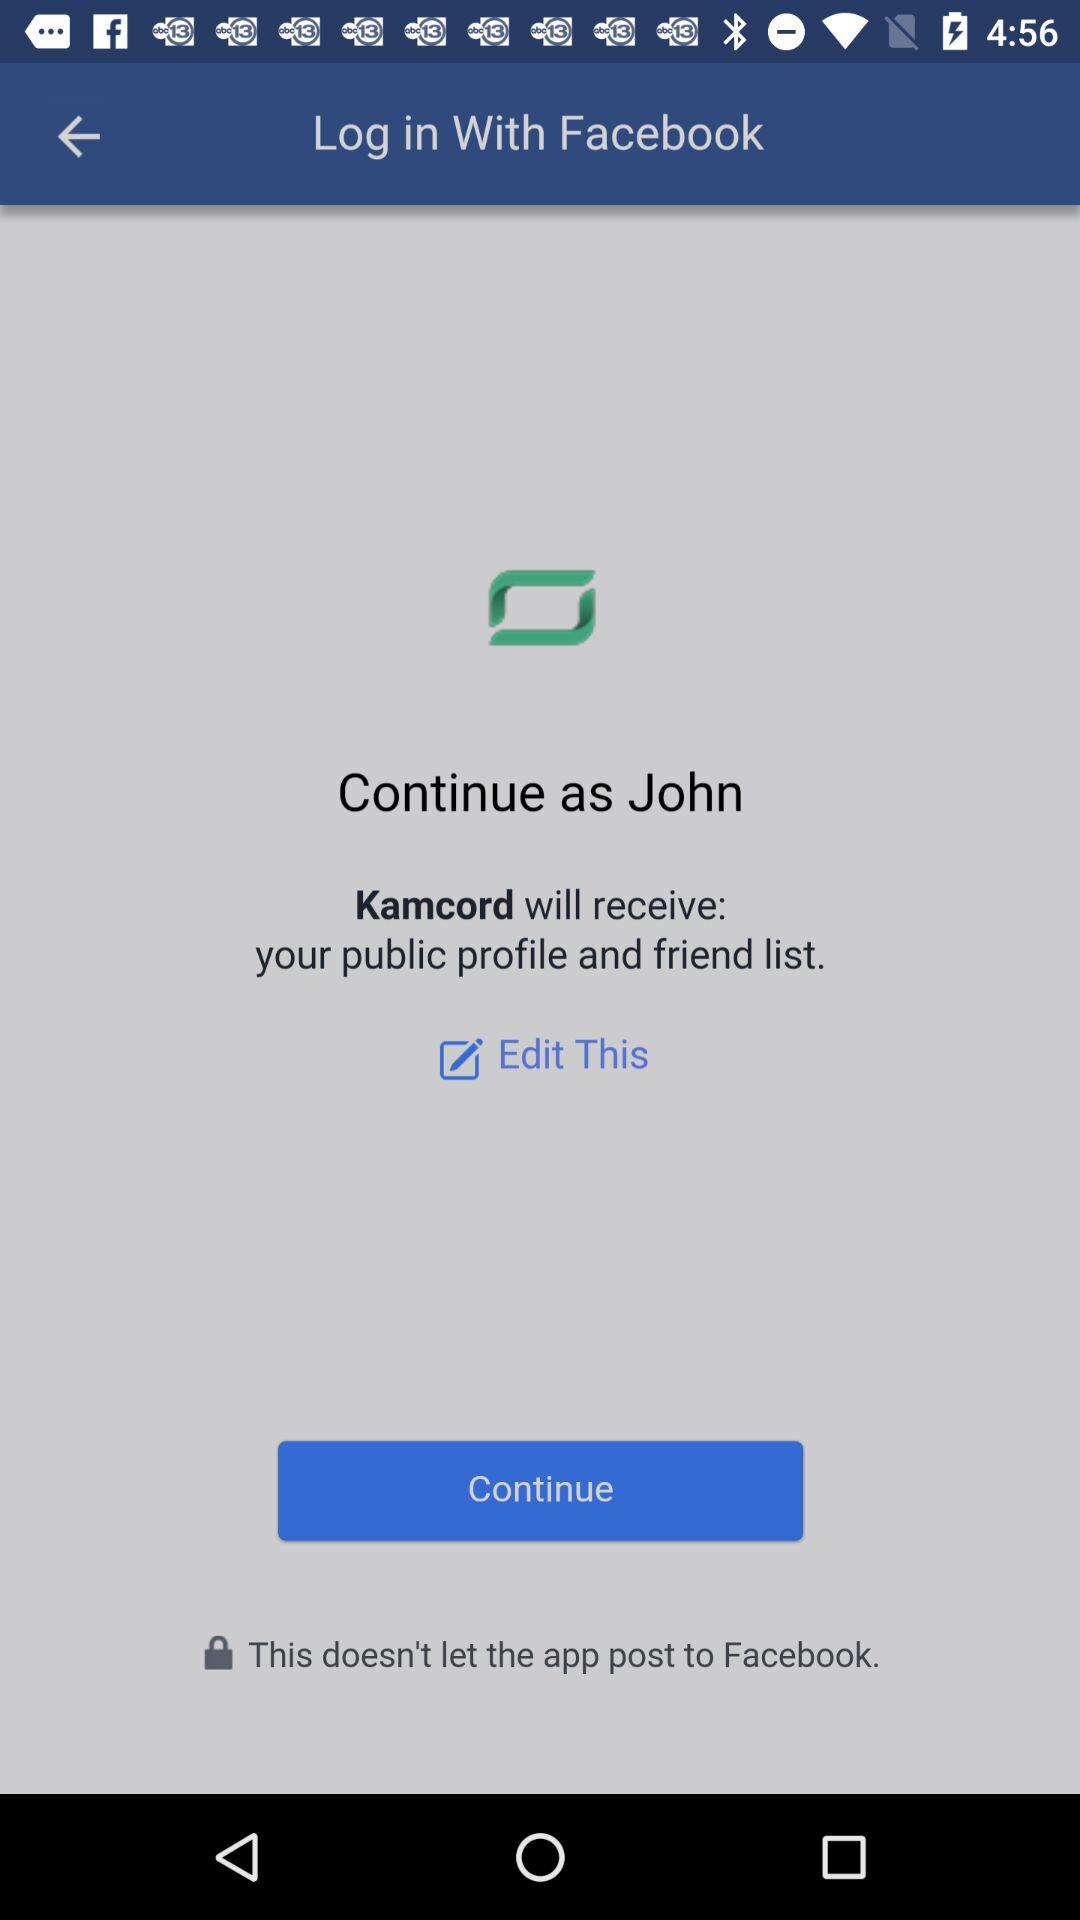Through what application is the person logging in? The person is logging in through "Facebook". 